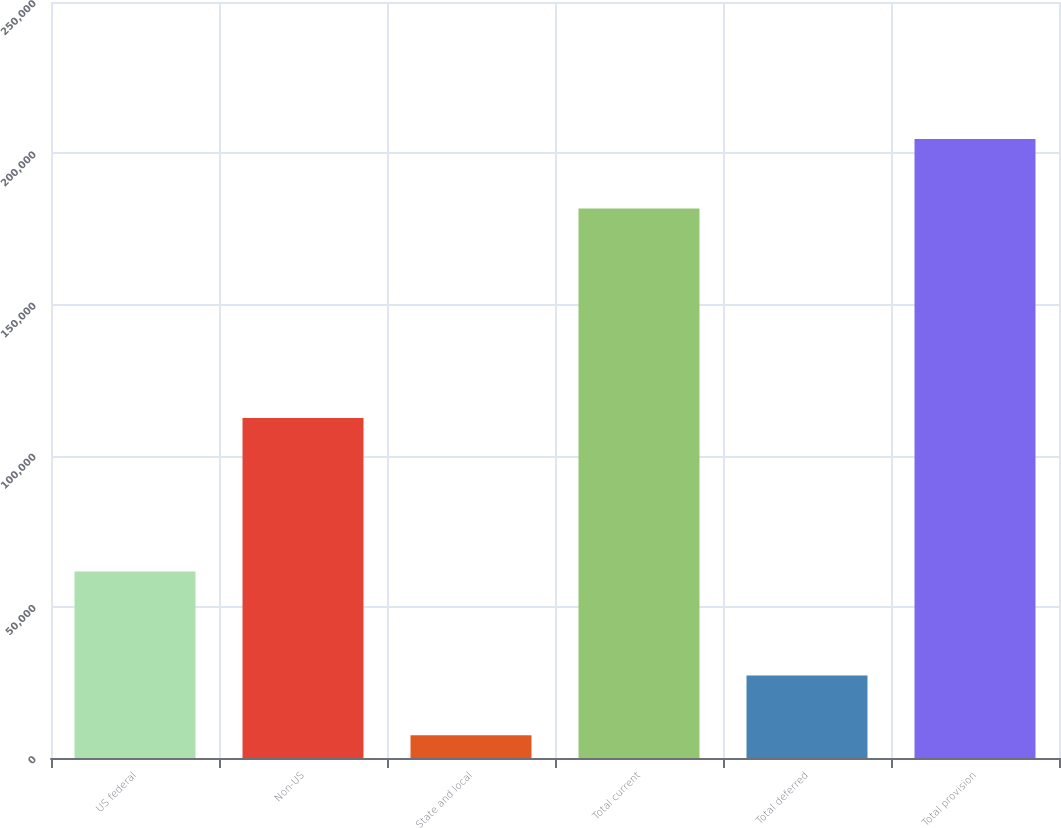Convert chart. <chart><loc_0><loc_0><loc_500><loc_500><bar_chart><fcel>US federal<fcel>Non-US<fcel>State and local<fcel>Total current<fcel>Total deferred<fcel>Total provision<nl><fcel>61670<fcel>112471<fcel>7537<fcel>181678<fcel>27253.4<fcel>204701<nl></chart> 